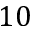<formula> <loc_0><loc_0><loc_500><loc_500>1 0</formula> 